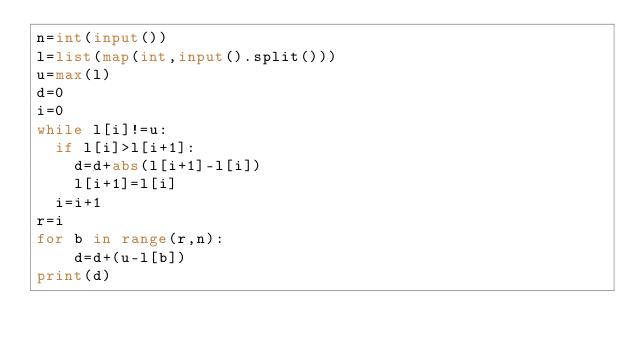<code> <loc_0><loc_0><loc_500><loc_500><_Python_>n=int(input())
l=list(map(int,input().split()))
u=max(l)
d=0
i=0
while l[i]!=u:
  if l[i]>l[i+1]:
    d=d+abs(l[i+1]-l[i])
    l[i+1]=l[i] 
  i=i+1
r=i
for b in range(r,n):
    d=d+(u-l[b])
print(d)
</code> 